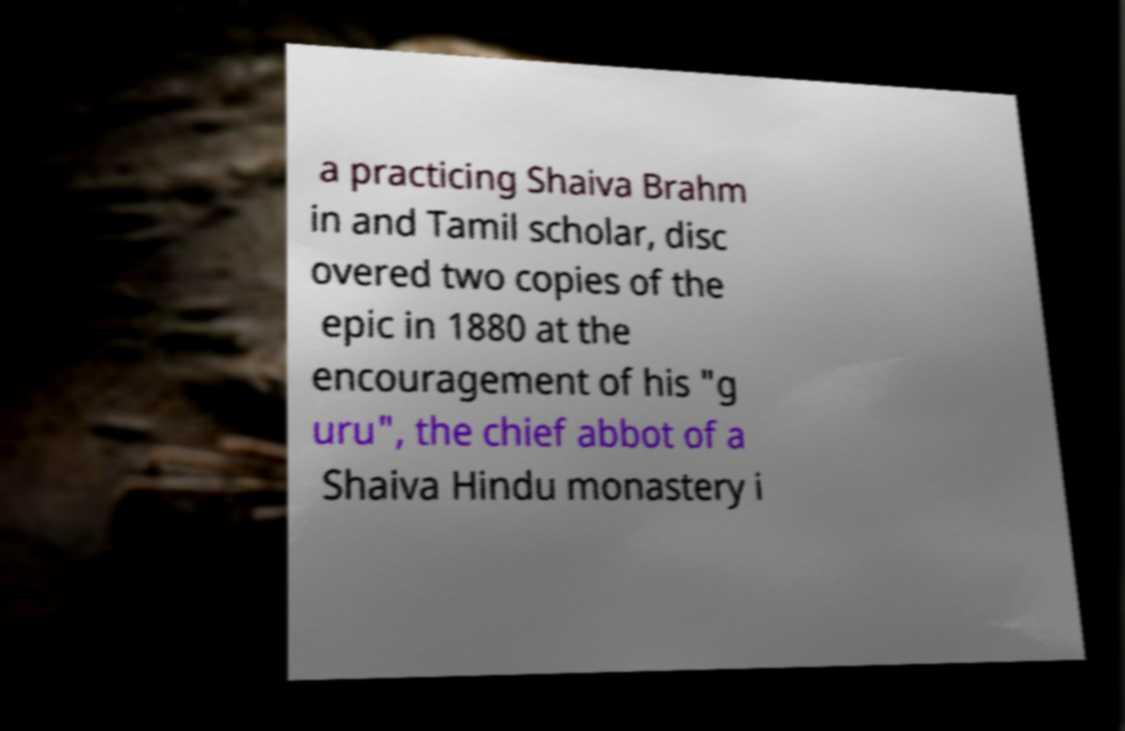Please identify and transcribe the text found in this image. a practicing Shaiva Brahm in and Tamil scholar, disc overed two copies of the epic in 1880 at the encouragement of his "g uru", the chief abbot of a Shaiva Hindu monastery i 